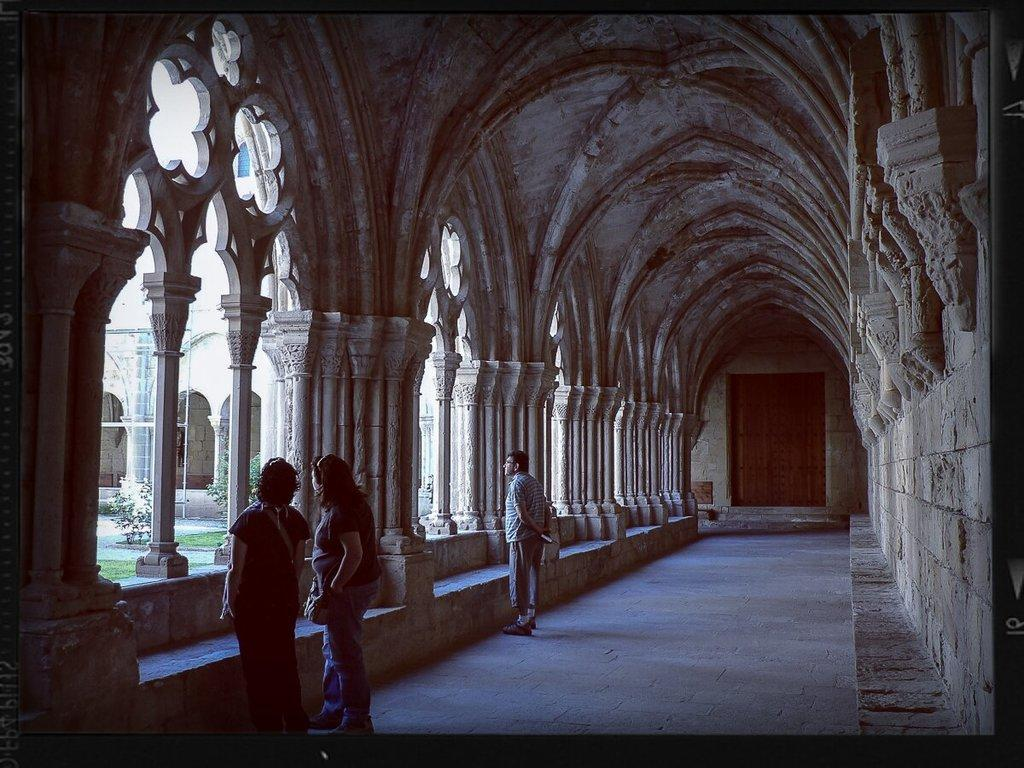Who or what can be seen in the image? There are people in the image. What type of structures are visible in the image? There are buildings in the image. What can be seen in the background of the image? Metal rods and plants are visible in the background of the image. What type of net is being used by the committee in the image? There is no committee or net present in the image. 